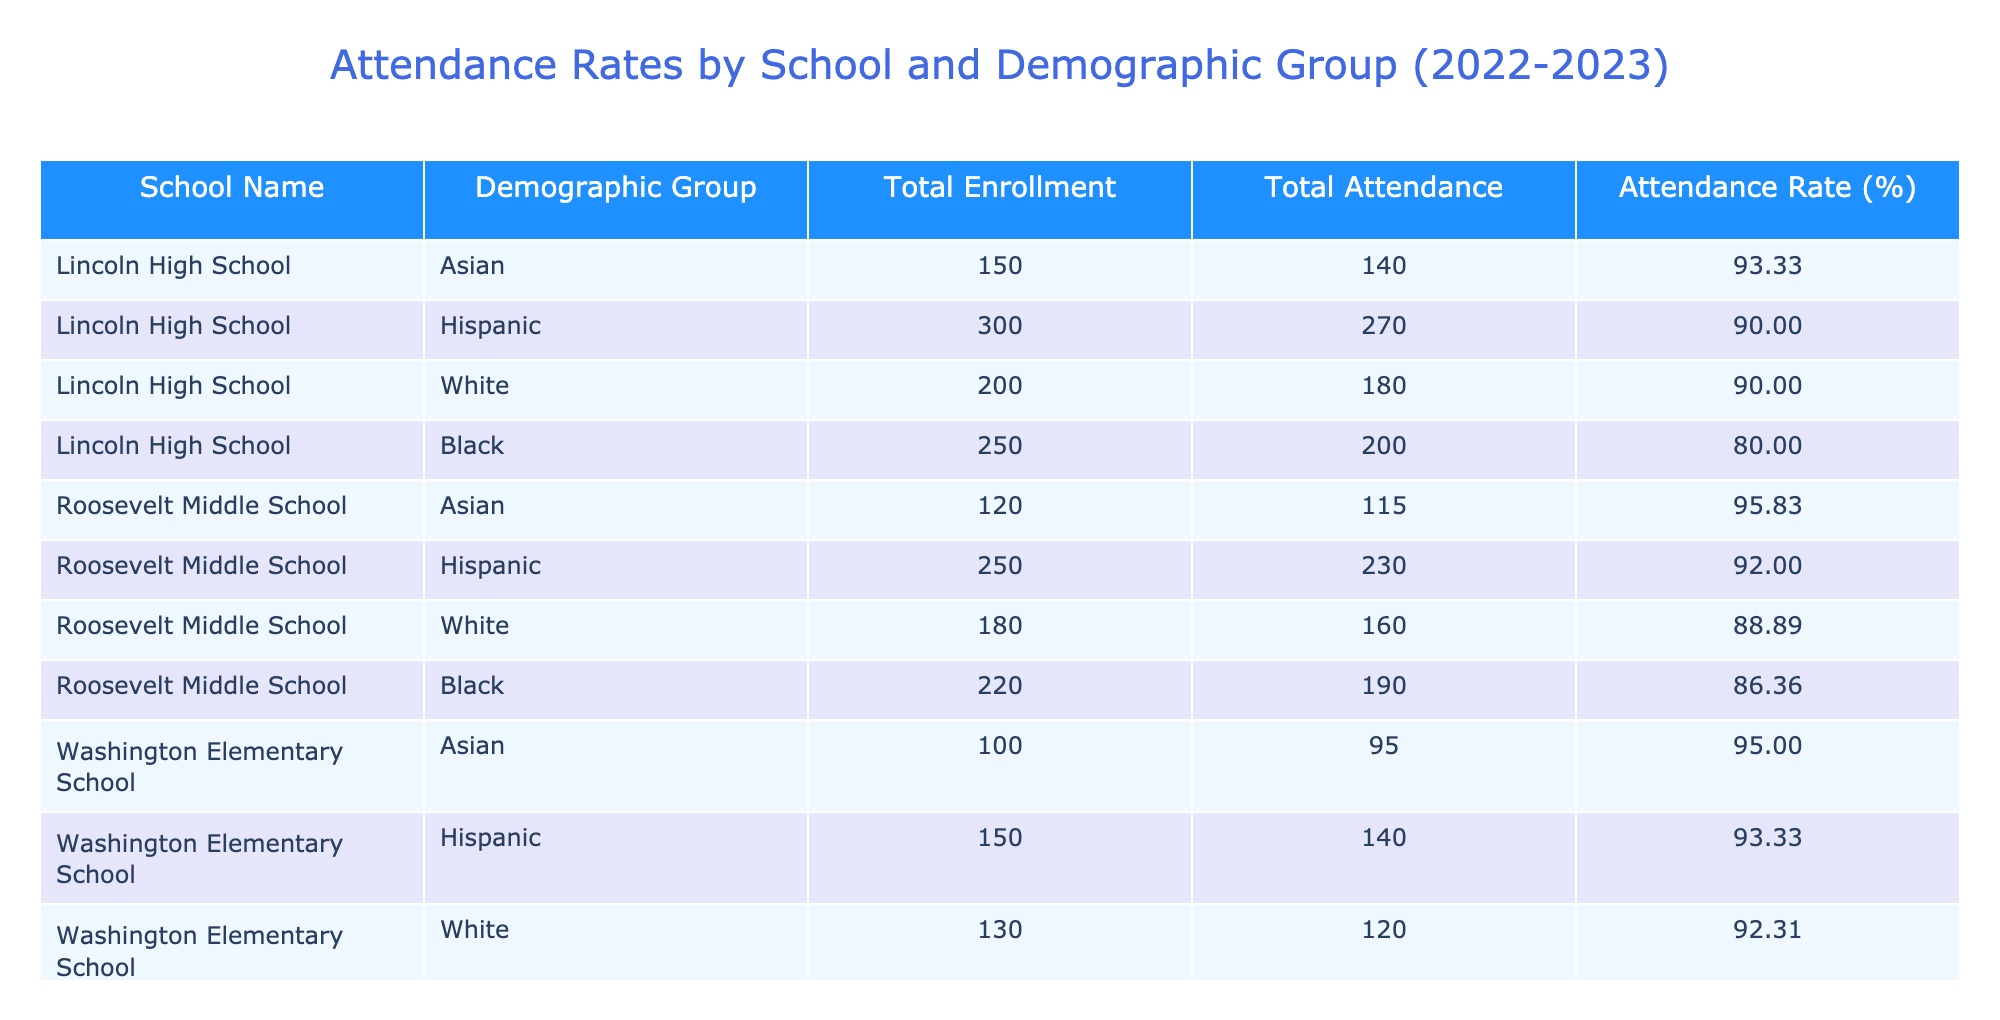What is the attendance rate for Hispanic students at Lincoln High School? The attendance rate for Hispanic students is listed in the table under Lincoln High School, which shows an attendance rate of 90.00%.
Answer: 90.00% What is the total enrollment for students from the White demographic group at Roosevelt Middle School? Referencing the table, Roosevelt Middle School has a total enrollment of 180 for White students.
Answer: 180 How many total students attended Lincoln High School? Summing up the total attendance for each demographic group at Lincoln High School, we have 140 (Asian) + 270 (Hispanic) + 180 (White) + 200 (Black) = 1090 total attendees.
Answer: 1090 Are there more Asian or Black students enrolled at Washington Elementary School? The table shows 100 Asian students and 160 Black students enrolled at Washington Elementary School. Since 160 is greater than 100, there are more Black students enrolled.
Answer: Yes What is the average attendance rate for all the demographic groups at Roosevelt Middle School? To find the average attendance rate for Roosevelt Middle School, we take the rates: 95.83 + 92.00 + 88.89 + 86.36 = 363.08 and divide by the number of groups (4): 363.08 / 4 = 90.77.
Answer: 90.77 Which school has the highest attendance rate for Black students? Looking at the table, Washington Elementary School has an attendance rate of 93.75% for Black students, which is higher compared to Lincoln High School (80.00%) and Roosevelt Middle School (86.36%).
Answer: Washington Elementary School How many more students attended Roosevelt Middle School than Washington Elementary School in the Asian demographic group? The table indicates that Roosevelt Middle School had 115 students attend, while Washington Elementary School had 95 students in the Asian group. Therefore, 115 - 95 = 20 more students attended Roosevelt Middle School.
Answer: 20 What demographic group has the lowest attendance rate at Lincoln High School? The table shows that Black students at Lincoln High School had the lowest attendance rate of 80.00%, lower than Asian (93.33%), Hispanic (90.00%), and White (90.00%).
Answer: Black students What is the total attendance for all schools combined? By summing the Total Attendance column for each demographic from all schools, we find: 140 + 270 + 180 + 200 + 115 + 230 + 160 + 190 + 95 + 140 + 120 + 150 =  1950 total attendees across all schools and demographics.
Answer: 1950 